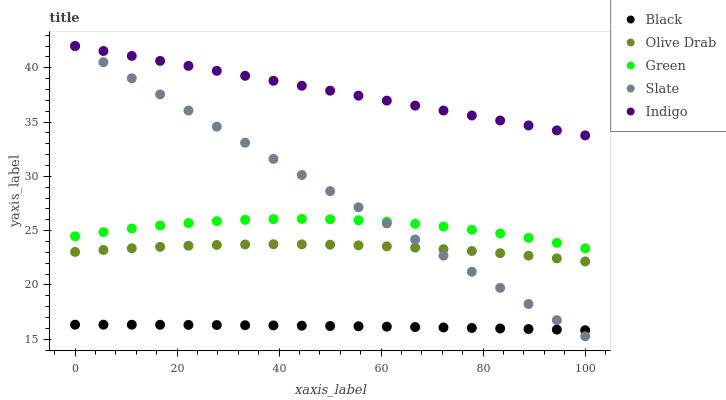Does Black have the minimum area under the curve?
Answer yes or no. Yes. Does Indigo have the maximum area under the curve?
Answer yes or no. Yes. Does Slate have the minimum area under the curve?
Answer yes or no. No. Does Slate have the maximum area under the curve?
Answer yes or no. No. Is Slate the smoothest?
Answer yes or no. Yes. Is Green the roughest?
Answer yes or no. Yes. Is Black the smoothest?
Answer yes or no. No. Is Black the roughest?
Answer yes or no. No. Does Slate have the lowest value?
Answer yes or no. Yes. Does Black have the lowest value?
Answer yes or no. No. Does Indigo have the highest value?
Answer yes or no. Yes. Does Black have the highest value?
Answer yes or no. No. Is Olive Drab less than Green?
Answer yes or no. Yes. Is Green greater than Olive Drab?
Answer yes or no. Yes. Does Slate intersect Green?
Answer yes or no. Yes. Is Slate less than Green?
Answer yes or no. No. Is Slate greater than Green?
Answer yes or no. No. Does Olive Drab intersect Green?
Answer yes or no. No. 